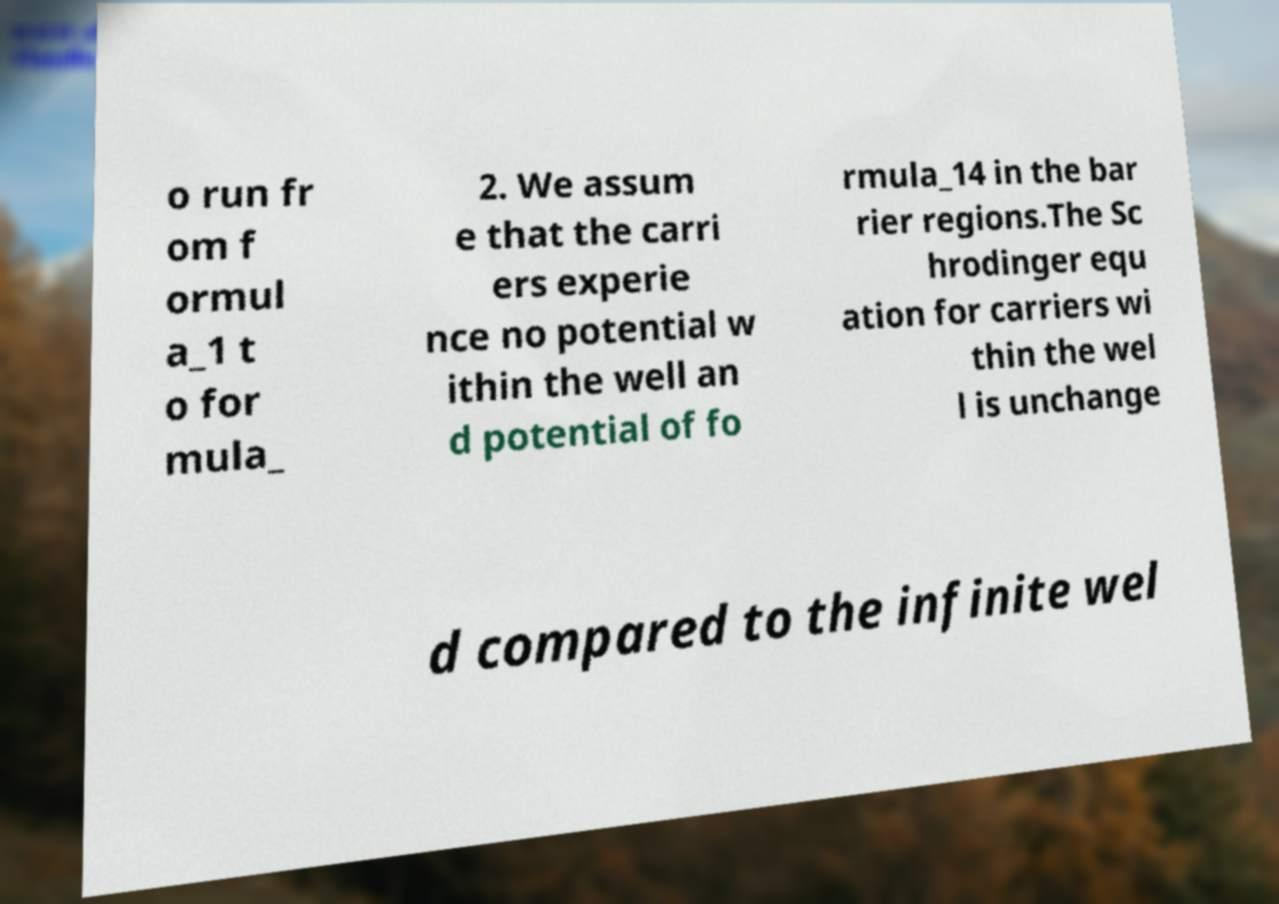I need the written content from this picture converted into text. Can you do that? o run fr om f ormul a_1 t o for mula_ 2. We assum e that the carri ers experie nce no potential w ithin the well an d potential of fo rmula_14 in the bar rier regions.The Sc hrodinger equ ation for carriers wi thin the wel l is unchange d compared to the infinite wel 